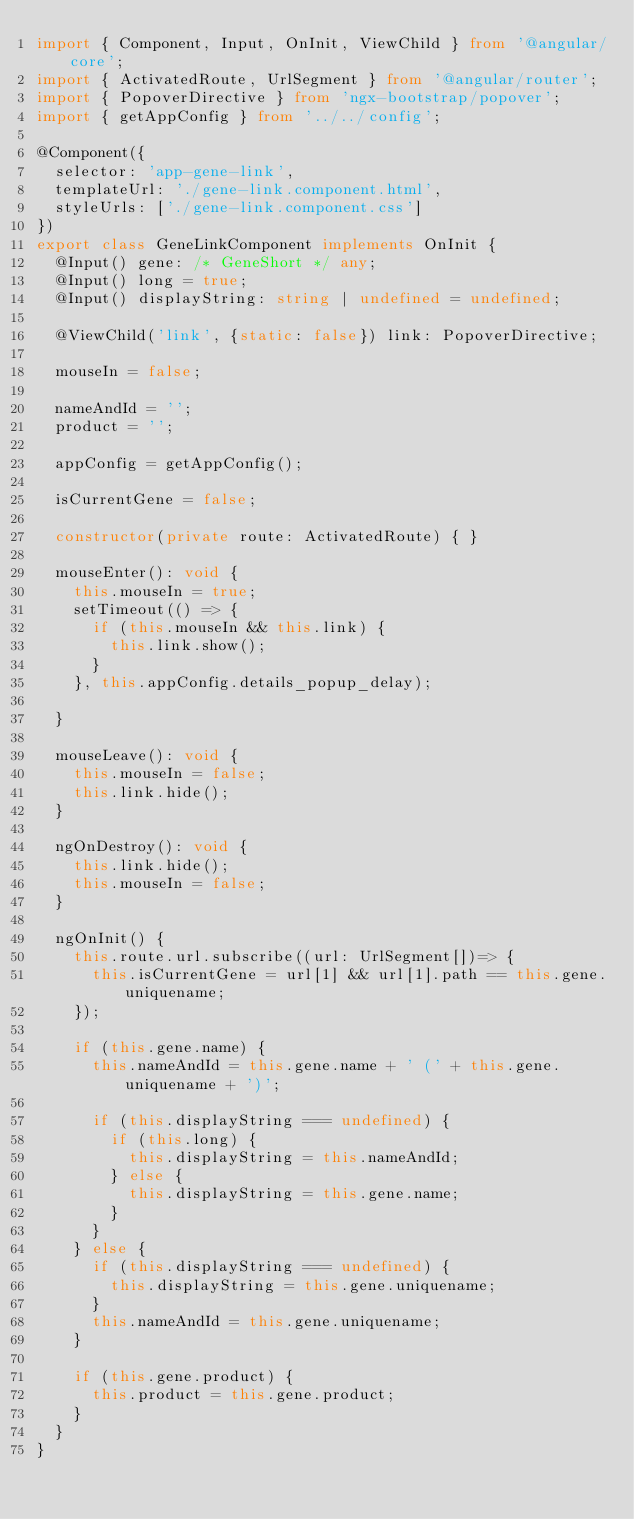Convert code to text. <code><loc_0><loc_0><loc_500><loc_500><_TypeScript_>import { Component, Input, OnInit, ViewChild } from '@angular/core';
import { ActivatedRoute, UrlSegment } from '@angular/router';
import { PopoverDirective } from 'ngx-bootstrap/popover';
import { getAppConfig } from '../../config';

@Component({
  selector: 'app-gene-link',
  templateUrl: './gene-link.component.html',
  styleUrls: ['./gene-link.component.css']
})
export class GeneLinkComponent implements OnInit {
  @Input() gene: /* GeneShort */ any;
  @Input() long = true;
  @Input() displayString: string | undefined = undefined;

  @ViewChild('link', {static: false}) link: PopoverDirective;

  mouseIn = false;

  nameAndId = '';
  product = '';

  appConfig = getAppConfig();

  isCurrentGene = false;

  constructor(private route: ActivatedRoute) { }

  mouseEnter(): void {
    this.mouseIn = true;
    setTimeout(() => {
      if (this.mouseIn && this.link) {
        this.link.show();
      }
    }, this.appConfig.details_popup_delay);

  }

  mouseLeave(): void {
    this.mouseIn = false;
    this.link.hide();
  }

  ngOnDestroy(): void {
    this.link.hide();
    this.mouseIn = false;
  }

  ngOnInit() {
    this.route.url.subscribe((url: UrlSegment[])=> {
      this.isCurrentGene = url[1] && url[1].path == this.gene.uniquename;
    });

    if (this.gene.name) {
      this.nameAndId = this.gene.name + ' (' + this.gene.uniquename + ')';

      if (this.displayString === undefined) {
        if (this.long) {
          this.displayString = this.nameAndId;
        } else {
          this.displayString = this.gene.name;
        }
      }
    } else {
      if (this.displayString === undefined) {
        this.displayString = this.gene.uniquename;
      }
      this.nameAndId = this.gene.uniquename;
    }

    if (this.gene.product) {
      this.product = this.gene.product;
    }
  }
}
</code> 